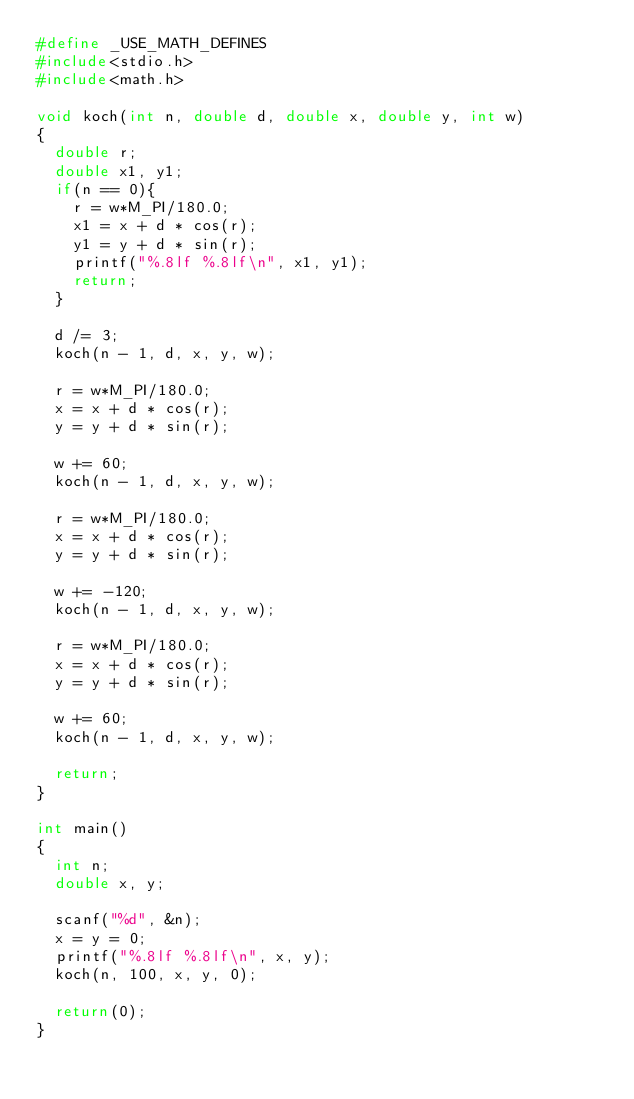Convert code to text. <code><loc_0><loc_0><loc_500><loc_500><_C_>#define _USE_MATH_DEFINES
#include<stdio.h>
#include<math.h>

void koch(int n, double d, double x, double y, int w)
{
	double r;
	double x1, y1;
	if(n == 0){
		r = w*M_PI/180.0;
		x1 = x + d * cos(r);
		y1 = y + d * sin(r);
		printf("%.8lf %.8lf\n", x1, y1);
		return;
	}

	d /= 3;
	koch(n - 1, d, x, y, w);

	r = w*M_PI/180.0;
	x = x + d * cos(r);
	y = y + d * sin(r);

	w += 60;
	koch(n - 1, d, x, y, w);

	r = w*M_PI/180.0;
	x = x + d * cos(r);
	y = y + d * sin(r);

	w += -120;
	koch(n - 1, d, x, y, w);

	r = w*M_PI/180.0;
	x = x + d * cos(r);
	y = y + d * sin(r);

	w += 60;
	koch(n - 1, d, x, y, w);

	return;
}

int main()
{
	int n;
	double x, y;

	scanf("%d", &n);
	x = y = 0;
	printf("%.8lf %.8lf\n", x, y);
	koch(n, 100, x, y, 0);

	return(0);
}</code> 